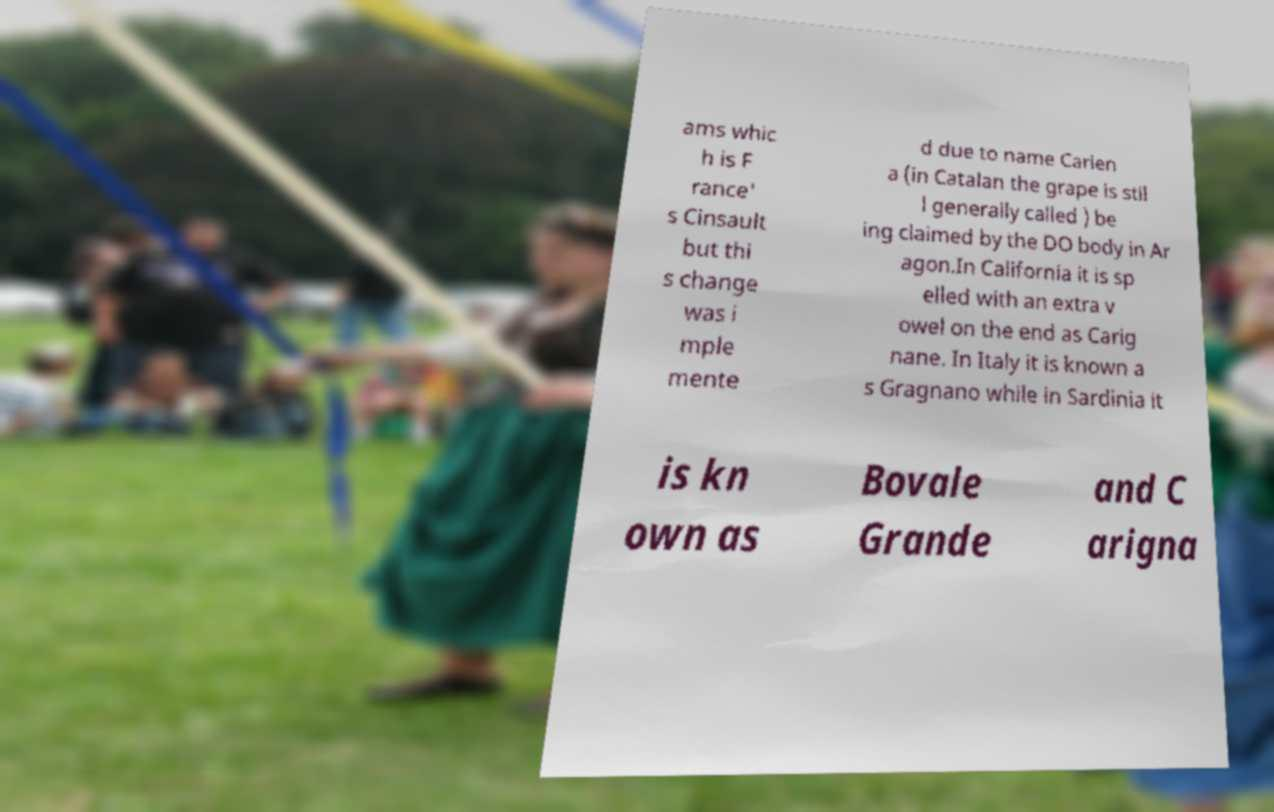I need the written content from this picture converted into text. Can you do that? ams whic h is F rance' s Cinsault but thi s change was i mple mente d due to name Carien a (in Catalan the grape is stil l generally called ) be ing claimed by the DO body in Ar agon.In California it is sp elled with an extra v owel on the end as Carig nane. In Italy it is known a s Gragnano while in Sardinia it is kn own as Bovale Grande and C arigna 